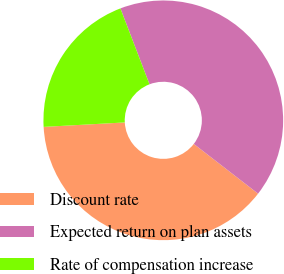Convert chart. <chart><loc_0><loc_0><loc_500><loc_500><pie_chart><fcel>Discount rate<fcel>Expected return on plan assets<fcel>Rate of compensation increase<nl><fcel>38.65%<fcel>41.31%<fcel>20.05%<nl></chart> 